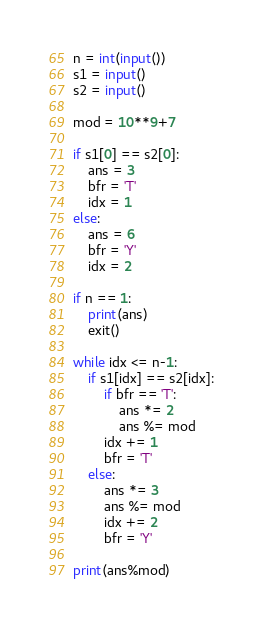Convert code to text. <code><loc_0><loc_0><loc_500><loc_500><_Python_>n = int(input())
s1 = input()
s2 = input()

mod = 10**9+7

if s1[0] == s2[0]:
    ans = 3
    bfr = 'T'
    idx = 1
else:
    ans = 6
    bfr = 'Y'
    idx = 2

if n == 1:
    print(ans)
    exit()

while idx <= n-1:
    if s1[idx] == s2[idx]:
        if bfr == 'T':
            ans *= 2
            ans %= mod
        idx += 1
        bfr = 'T'
    else:
        ans *= 3
        ans %= mod
        idx += 2
        bfr = 'Y'
        
print(ans%mod)</code> 